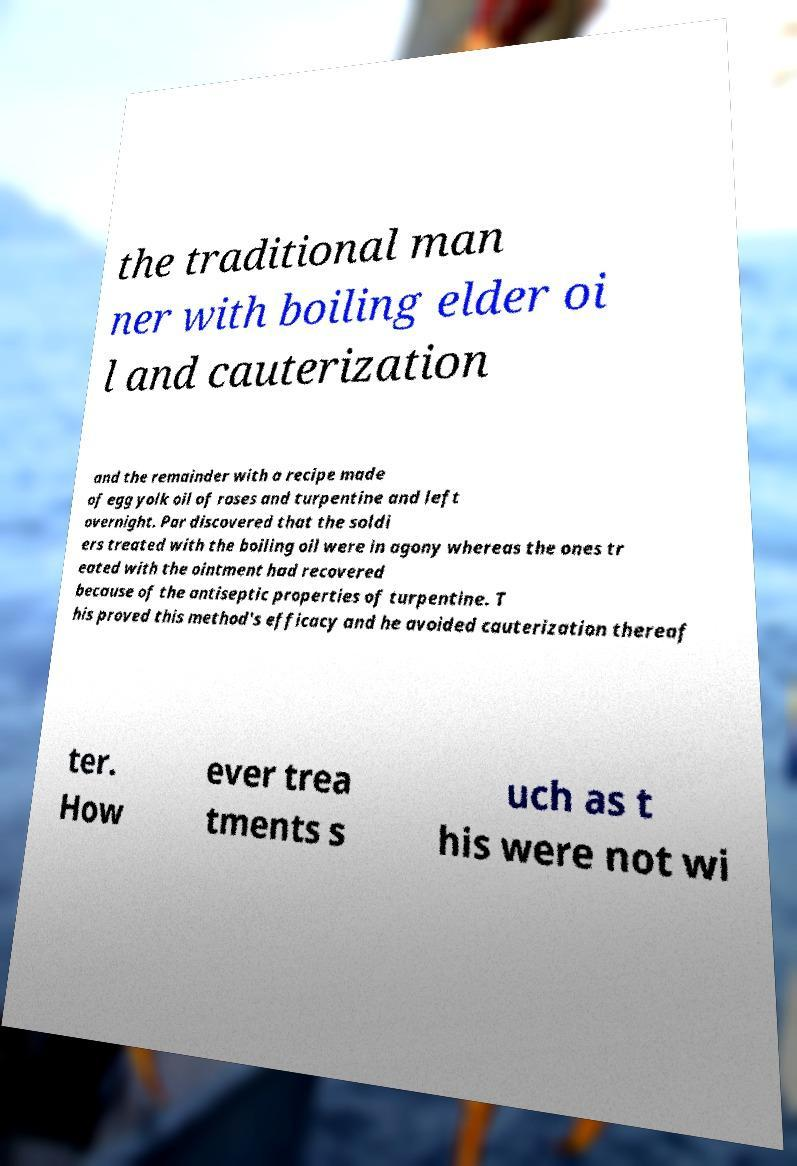For documentation purposes, I need the text within this image transcribed. Could you provide that? the traditional man ner with boiling elder oi l and cauterization and the remainder with a recipe made of egg yolk oil of roses and turpentine and left overnight. Par discovered that the soldi ers treated with the boiling oil were in agony whereas the ones tr eated with the ointment had recovered because of the antiseptic properties of turpentine. T his proved this method's efficacy and he avoided cauterization thereaf ter. How ever trea tments s uch as t his were not wi 